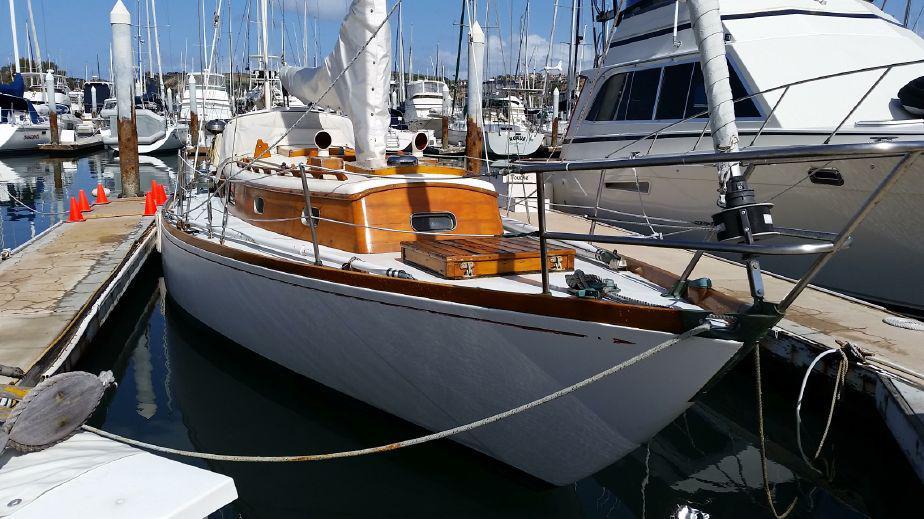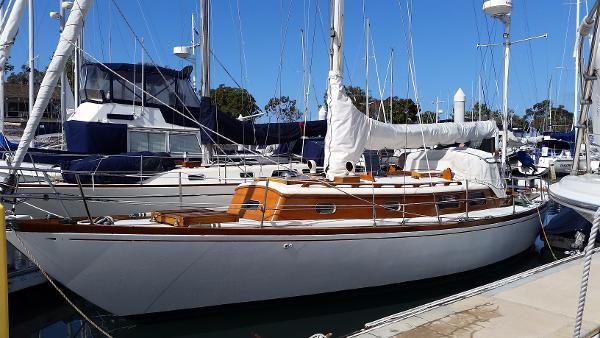The first image is the image on the left, the second image is the image on the right. Evaluate the accuracy of this statement regarding the images: "One of the images contains a single sailboat with three sails". Is it true? Answer yes or no. No. 